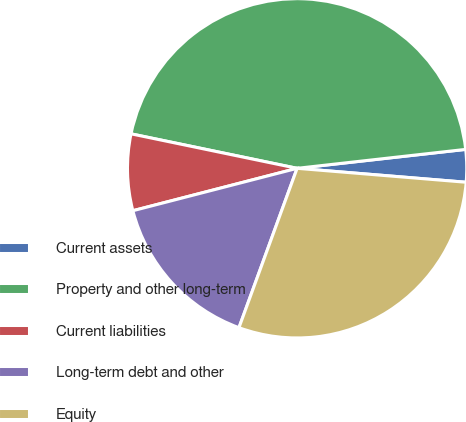<chart> <loc_0><loc_0><loc_500><loc_500><pie_chart><fcel>Current assets<fcel>Property and other long-term<fcel>Current liabilities<fcel>Long-term debt and other<fcel>Equity<nl><fcel>3.09%<fcel>44.96%<fcel>7.28%<fcel>15.41%<fcel>29.26%<nl></chart> 